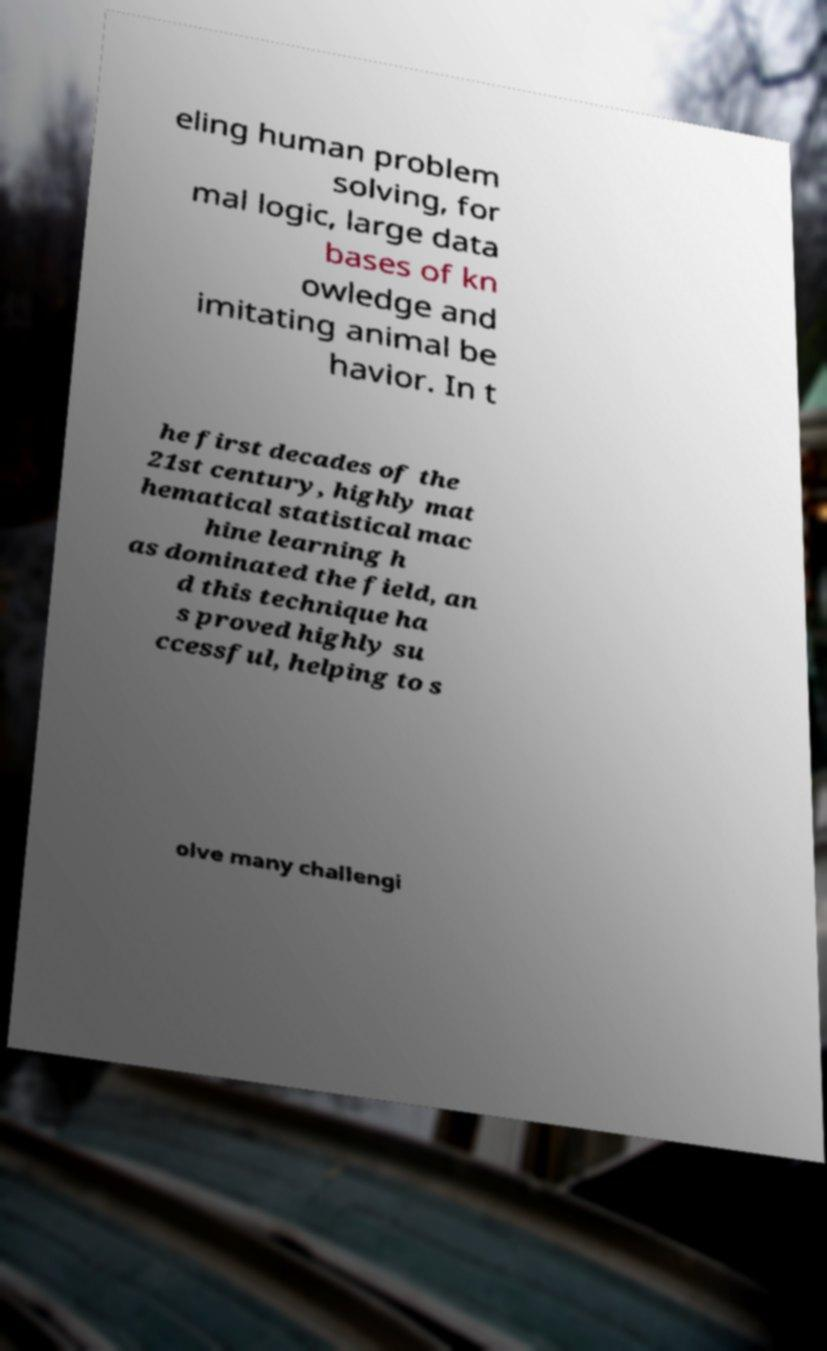Can you read and provide the text displayed in the image?This photo seems to have some interesting text. Can you extract and type it out for me? eling human problem solving, for mal logic, large data bases of kn owledge and imitating animal be havior. In t he first decades of the 21st century, highly mat hematical statistical mac hine learning h as dominated the field, an d this technique ha s proved highly su ccessful, helping to s olve many challengi 